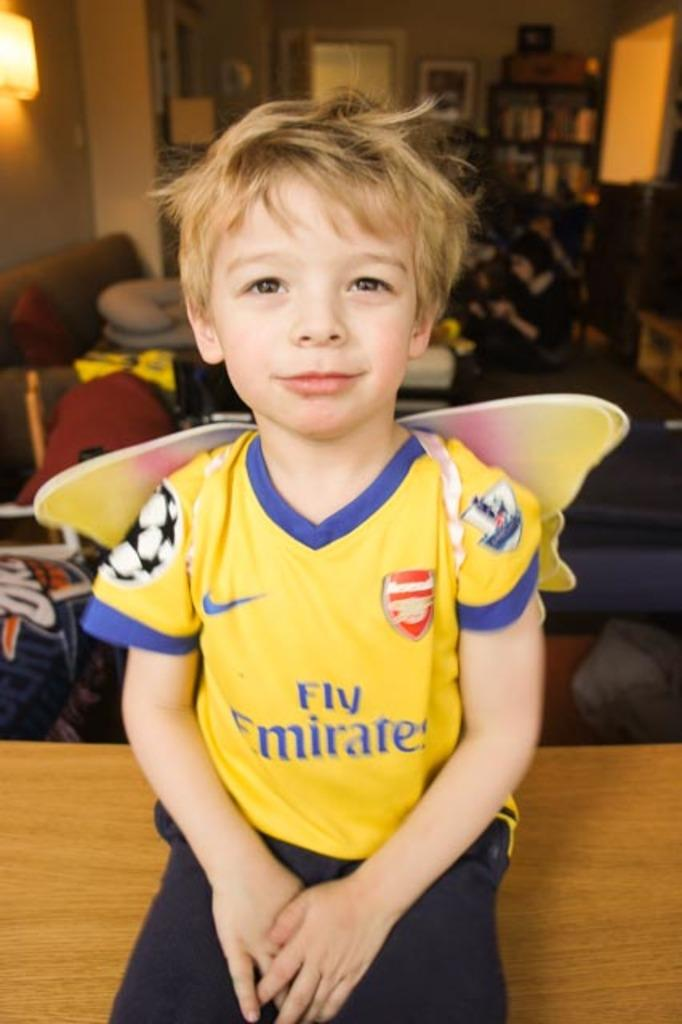Provide a one-sentence caption for the provided image. a boy with a winged shirt on that says Fly Emirates on the front, and has sports logos. 